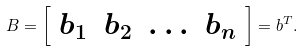Convert formula to latex. <formula><loc_0><loc_0><loc_500><loc_500>B = { \left [ \begin{array} { l l l l } { b _ { 1 } } & { b _ { 2 } } & { \dots } & { b _ { n } } \end{array} \right ] } = b ^ { T } .</formula> 